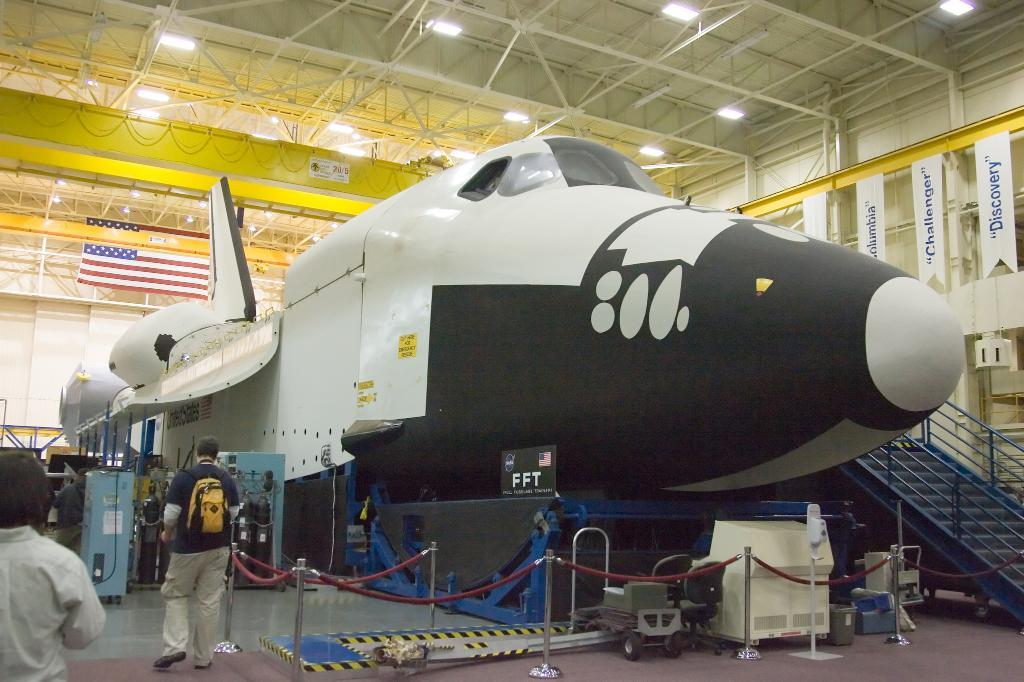What is the main subject of the image? The main subject of the image is an aircraft. Where is the aircraft located? The aircraft is inside a godown. What is surrounding the aircraft? There is a fence around the aircraft. What can be seen on the right side of the image? There are steps on the right side of the image. What is happening on the left side of the image? There are people walking on the left side of the image. What is the lighting condition in the image? There are lights over the ceiling in the image. What type of boundary is present between the aircraft and the people in the image? There is no specific boundary mentioned in the image; it only shows a fence around the aircraft and people walking on the left side. What is the desire of the aircraft in the image? Aircrafts do not have desires, as they are inanimate objects. 